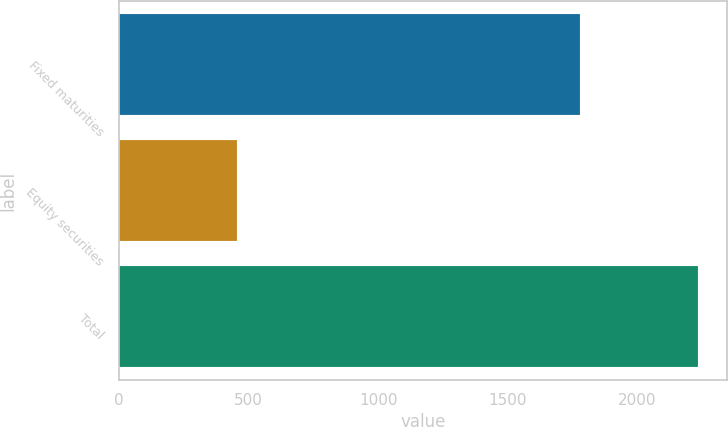Convert chart. <chart><loc_0><loc_0><loc_500><loc_500><bar_chart><fcel>Fixed maturities<fcel>Equity securities<fcel>Total<nl><fcel>1780<fcel>454<fcel>2234<nl></chart> 